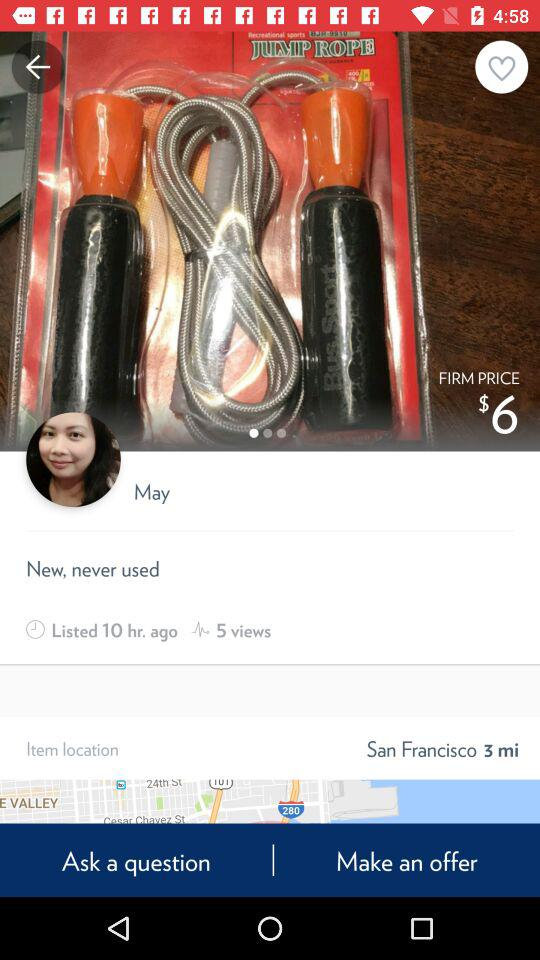How many views does this item have?
Answer the question using a single word or phrase. 5 